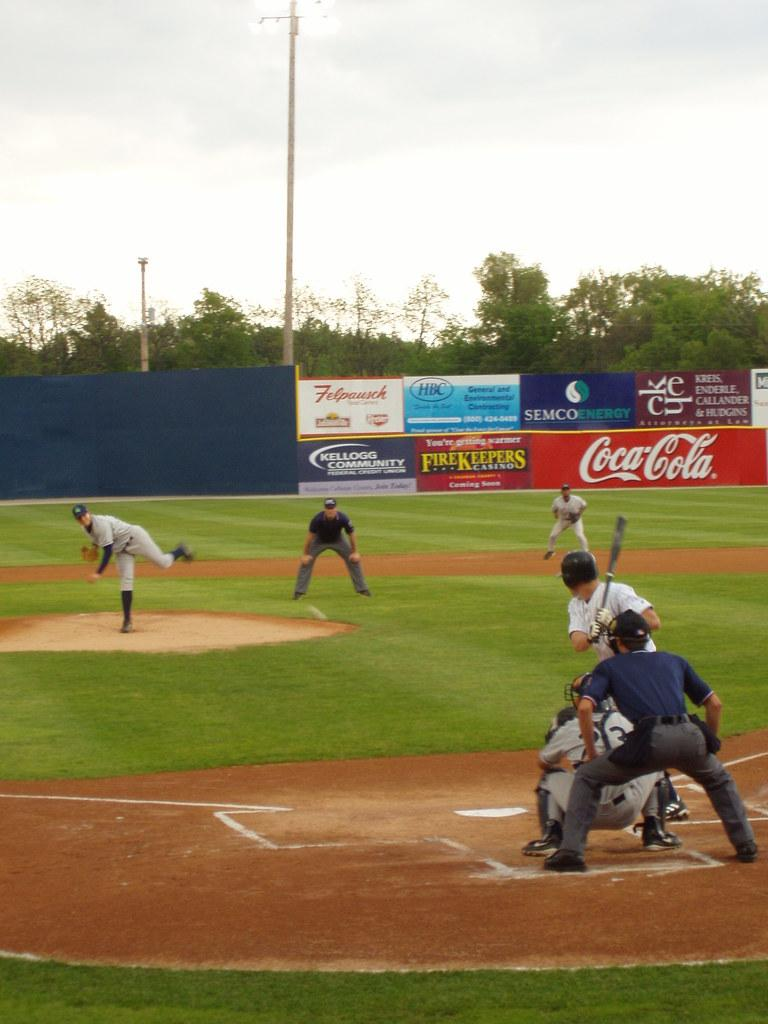<image>
Share a concise interpretation of the image provided. A baseball game is in progress with advertising signs in the background for Coca-Cola and other companies. 